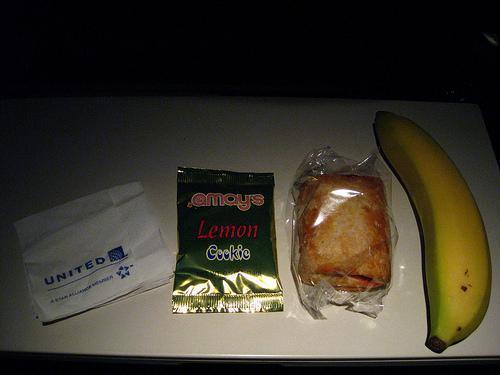How many bananas are there?
Give a very brief answer. 1. 